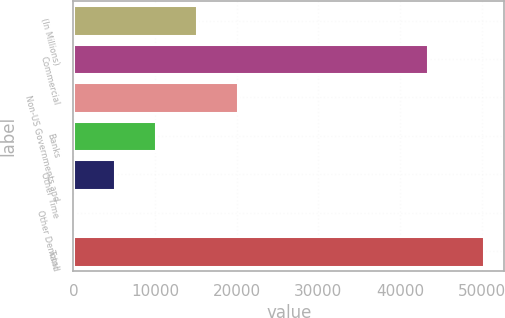<chart> <loc_0><loc_0><loc_500><loc_500><bar_chart><fcel>(In Millions)<fcel>Commercial<fcel>Non-US Governments and<fcel>Banks<fcel>Other Time<fcel>Other Demand<fcel>Total<nl><fcel>15085.1<fcel>43466.6<fcel>20111.2<fcel>10058.9<fcel>5032.76<fcel>6.6<fcel>50268.2<nl></chart> 